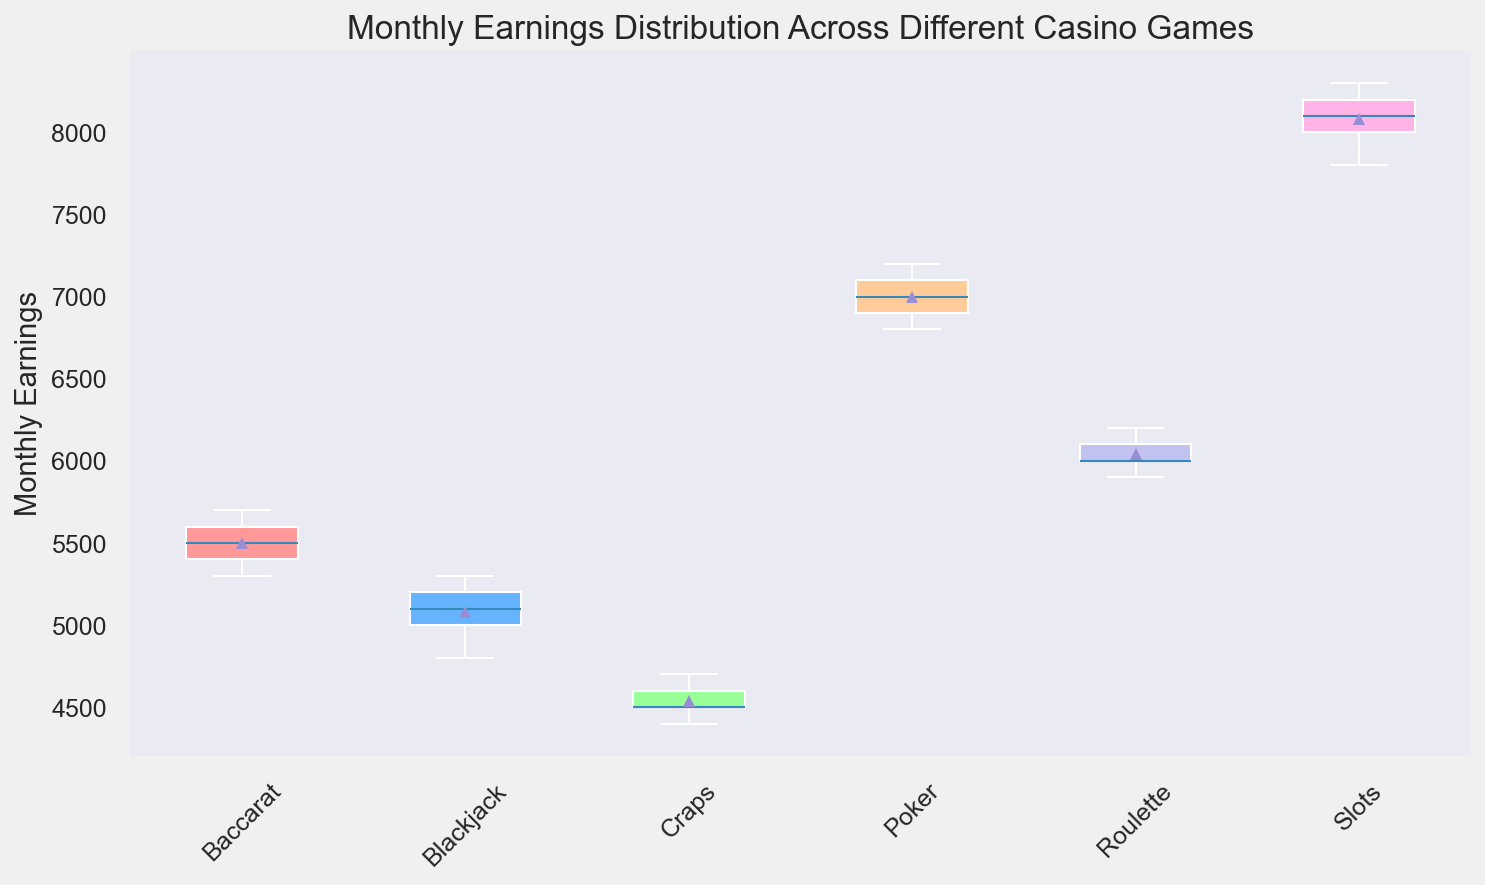Which casino game has the highest median monthly earnings? Looking at the box plot, the median is indicated by the horizontal line inside each box. The slot game shows the highest median line compared to the other games.
Answer: Slots Which casino game has the lowest quarterly difference between the mean and lowest monthly earnings? The lowest quarterly difference is found by subtracting the bottom whisker (minimum) from the mean (indicated by the dot). After analyzing all groups, Craps has the smallest difference.
Answer: Craps How do the monthly earnings distributions compare between Poker and Blackjack? By comparing the boxes, Poker and Blackjack have a similar size of interquartile range (IQR). However, the median and overall range (whiskers) of Poker is higher than those of Blackjack.
Answer: Poker has a higher median and range Which game type has the most consistent monthly earnings? Consistency can be interpreted by looking at the smallest IQR (size of the box). Blackjack and Baccarat have the smallest IQR of all the games, meaning their earnings are more consistent.
Answer: Blackjack and Baccarat Which games have their outliers displayed? What's the meaning of these visuals? None of the games show outliers. An outlier would be depicted as a point outside the whiskers in the boxplot, but none are shown here.
Answer: None, no outliers What is the range of monthly earnings for Roulette? The range is found by the difference between the top and bottom whiskers. For Roulette, it's 6200 (top whisker) minus 5900 (bottom whisker).
Answer: 300 Compare the interquartile range (IQR) of Slots and Craps. Which one is larger? The IQR is the range between the 1st (bottom of the box) and 3rd quartiles (top of the box). Comparing these, Slots has a larger IQR than Craps.
Answer: Slots Which game shows the widest variability in monthly earnings? The widest variability is seen in the game with the largest distance between the whiskers. Slots show the widest variability.
Answer: Slots Is the average monthly earning for Baccarat higher than that of Blackjack? The average monthly earnings are indicated by the mean (dots). By comparing the mean dots, Baccarat’s dot is slightly higher than Blackjack’s.
Answer: Yes 